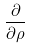<formula> <loc_0><loc_0><loc_500><loc_500>\frac { \partial } { \partial \rho }</formula> 